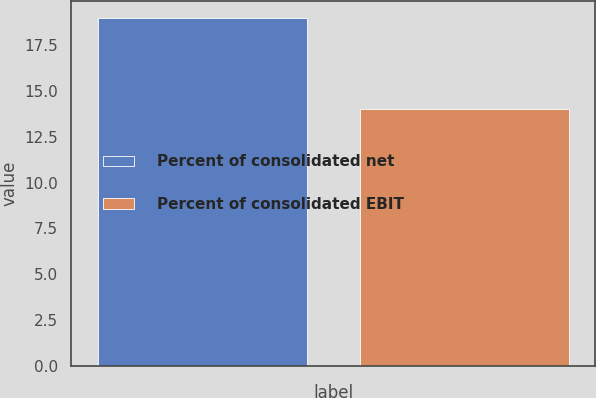Convert chart. <chart><loc_0><loc_0><loc_500><loc_500><bar_chart><fcel>Percent of consolidated net<fcel>Percent of consolidated EBIT<nl><fcel>19<fcel>14<nl></chart> 